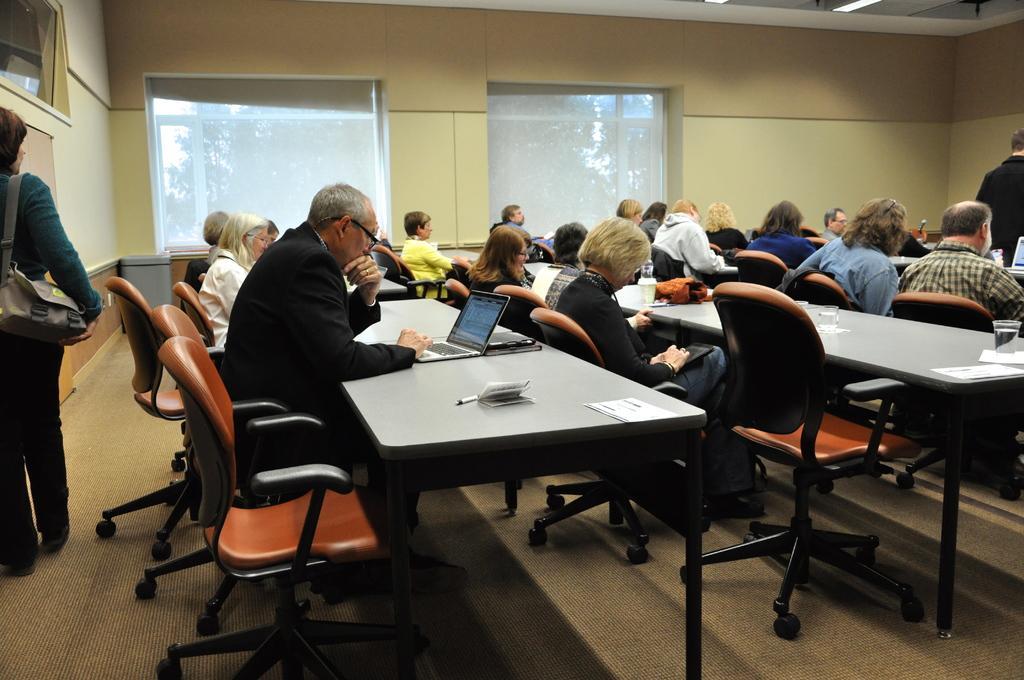Could you give a brief overview of what you see in this image? In this picture we have so many people are sitting on the chair in front of them table on the table we have laptops papers pens bottles And wallets back side we can see one woman is walking and she is carrying a backpack and one man is in standing position. 